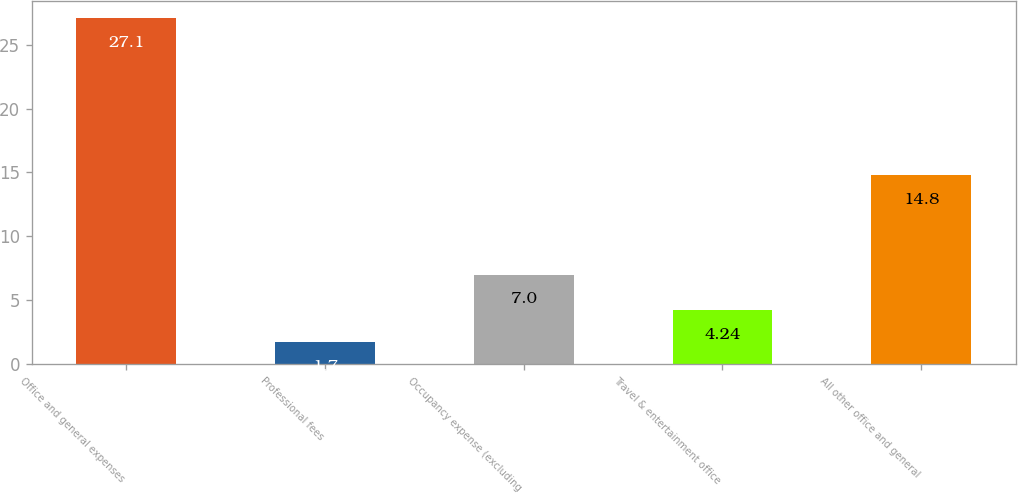Convert chart. <chart><loc_0><loc_0><loc_500><loc_500><bar_chart><fcel>Office and general expenses<fcel>Professional fees<fcel>Occupancy expense (excluding<fcel>Travel & entertainment office<fcel>All other office and general<nl><fcel>27.1<fcel>1.7<fcel>7<fcel>4.24<fcel>14.8<nl></chart> 